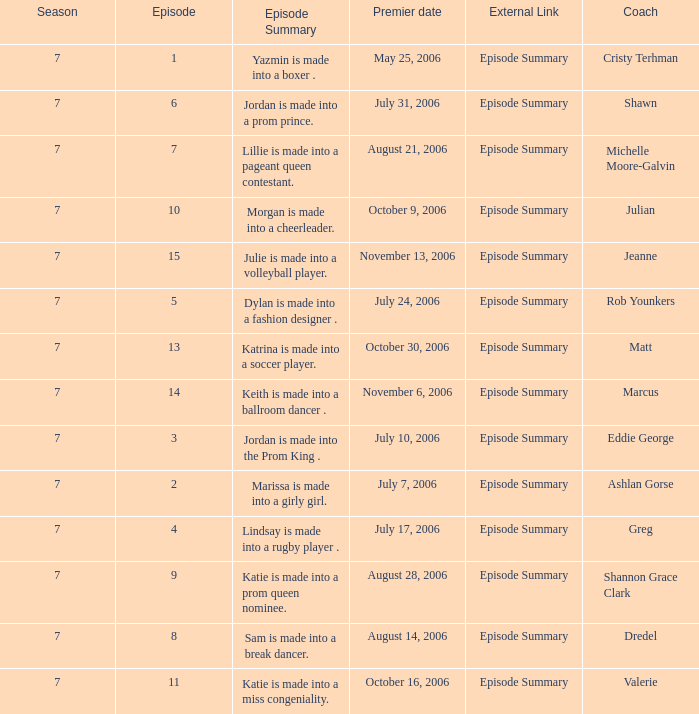What is the newest season? 7.0. 